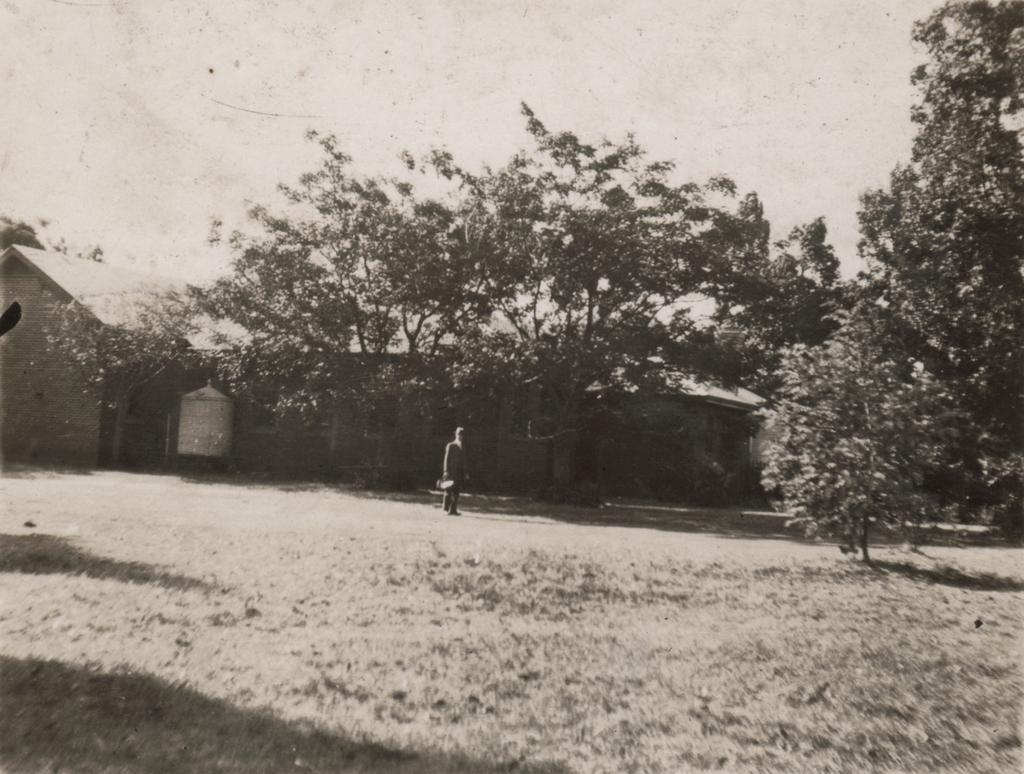Could you give a brief overview of what you see in this image? This is a black and white picture. Here we can see a person standing on the ground. This is house and there are trees. In the background there is sky. 